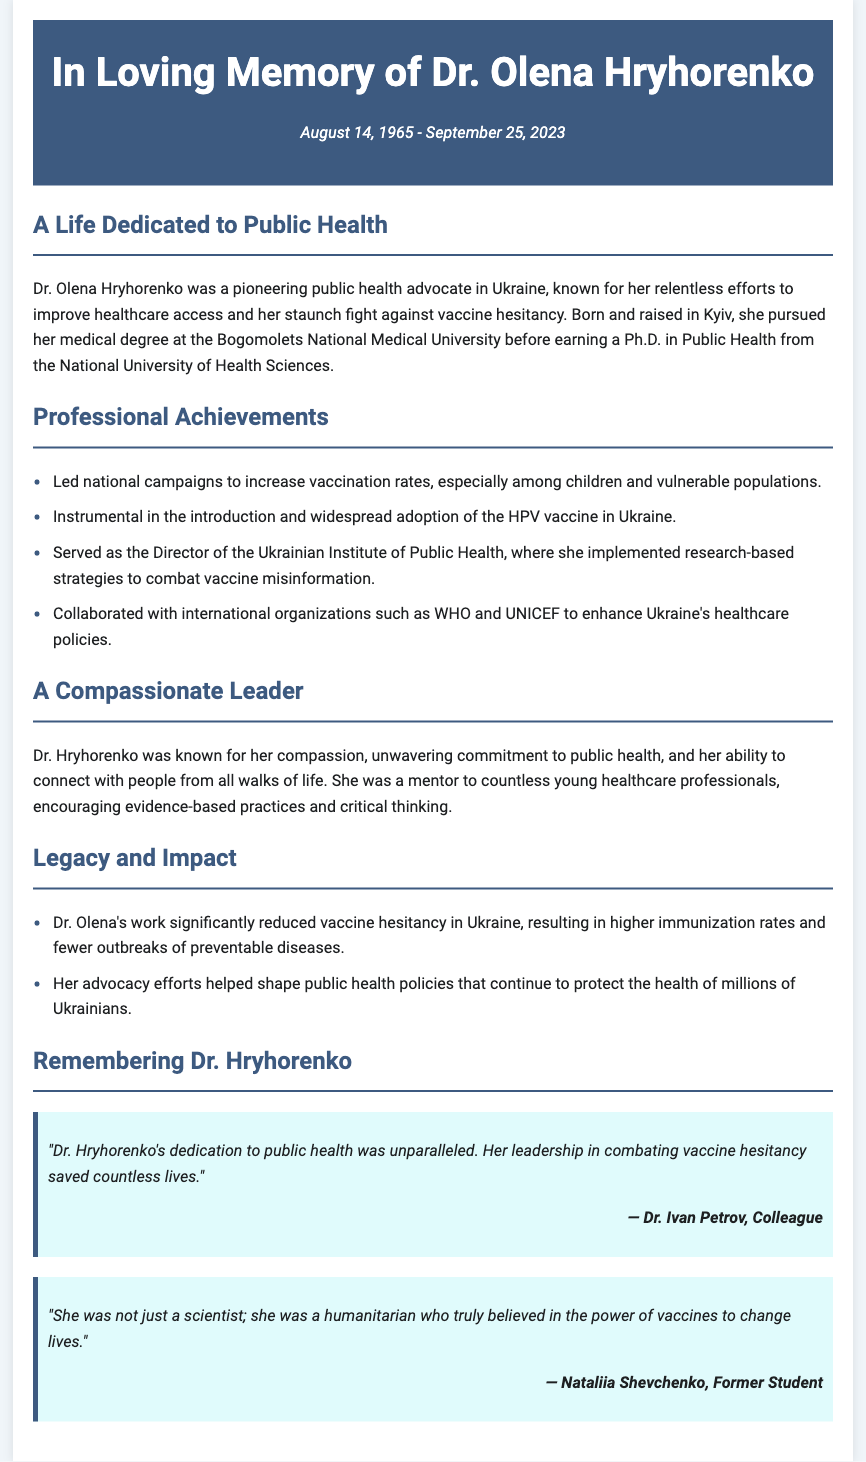What was Dr. Hryhorenko's birth date? Dr. Hryhorenko was born on August 14, 1965, as mentioned in the dates section of the obituary.
Answer: August 14, 1965 What was her role at the Ukrainian Institute of Public Health? Dr. Hryhorenko served as the Director of the Ukrainian Institute of Public Health, as stated in the Professional Achievements section.
Answer: Director Which vaccine did Dr. Hryhorenko help to introduce in Ukraine? The obituary highlights her role in the introduction and widespread adoption of the HPV vaccine in Ukraine.
Answer: HPV vaccine What is one of the main impacts of Dr. Hryhorenko's work? The document indicates that Dr. Hryhorenko's work significantly reduced vaccine hesitancy in Ukraine.
Answer: Reduced vaccine hesitancy Who praised Dr. Hryhorenko's dedication to public health? Dr. Ivan Petrov, a colleague, is quoted in the document praising her dedication to public health.
Answer: Dr. Ivan Petrov What did Dr. Hryhorenko encourage among young healthcare professionals? The obituary mentions that she encouraged evidence-based practices and critical thinking among young healthcare professionals.
Answer: Evidence-based practices How many years did Dr. Hryhorenko live? Dr. Hryhorenko passed away on September 25, 2023, and given her birth date, she lived for 58 years.
Answer: 58 years What organization did Dr. Hryhorenko collaborate with to enhance healthcare policies? The obituary states that she collaborated with WHO and UNICEF for enhancing healthcare policies.
Answer: WHO and UNICEF 